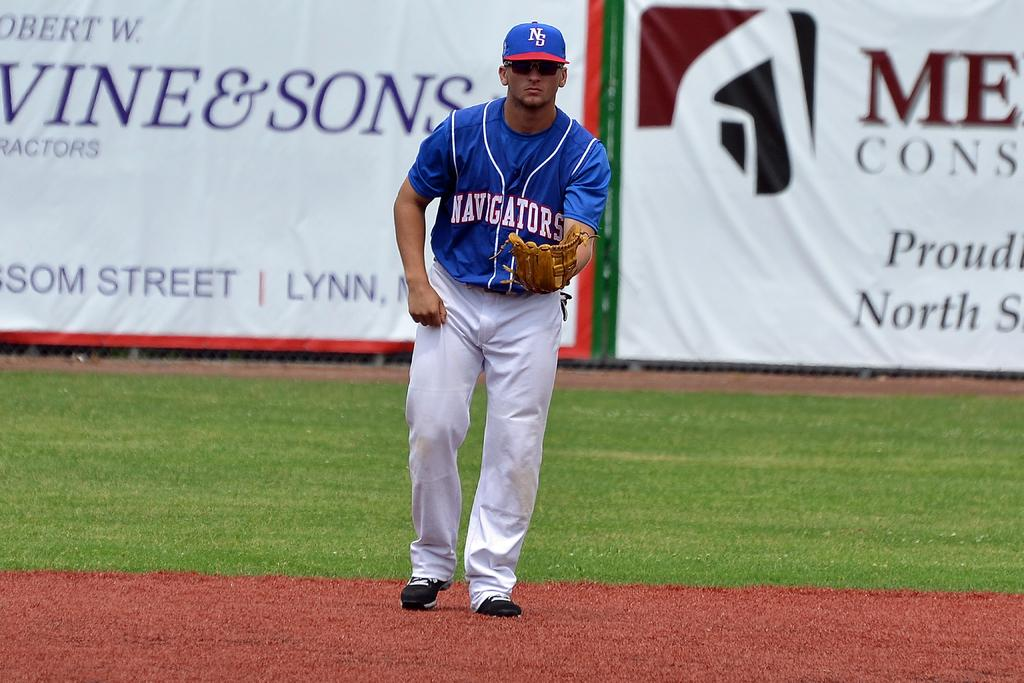<image>
Offer a succinct explanation of the picture presented. the word navigators that is on a jersey 